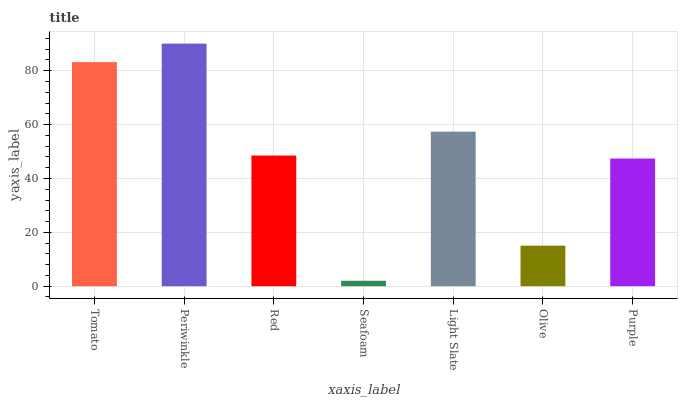Is Seafoam the minimum?
Answer yes or no. Yes. Is Periwinkle the maximum?
Answer yes or no. Yes. Is Red the minimum?
Answer yes or no. No. Is Red the maximum?
Answer yes or no. No. Is Periwinkle greater than Red?
Answer yes or no. Yes. Is Red less than Periwinkle?
Answer yes or no. Yes. Is Red greater than Periwinkle?
Answer yes or no. No. Is Periwinkle less than Red?
Answer yes or no. No. Is Red the high median?
Answer yes or no. Yes. Is Red the low median?
Answer yes or no. Yes. Is Tomato the high median?
Answer yes or no. No. Is Tomato the low median?
Answer yes or no. No. 